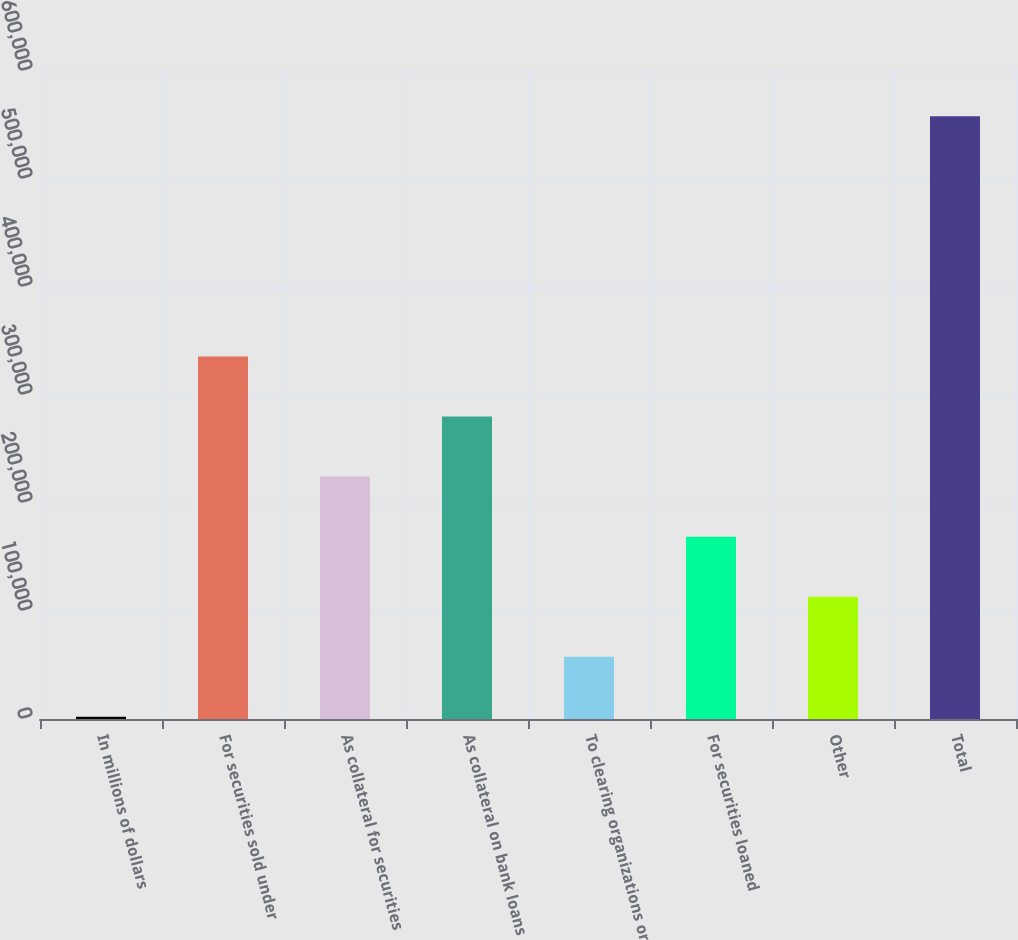Convert chart to OTSL. <chart><loc_0><loc_0><loc_500><loc_500><bar_chart><fcel>In millions of dollars<fcel>For securities sold under<fcel>As collateral for securities<fcel>As collateral on bank loans<fcel>To clearing organizations or<fcel>For securities loaned<fcel>Other<fcel>Total<nl><fcel>2009<fcel>335672<fcel>224451<fcel>280062<fcel>57619.5<fcel>168840<fcel>113230<fcel>558114<nl></chart> 